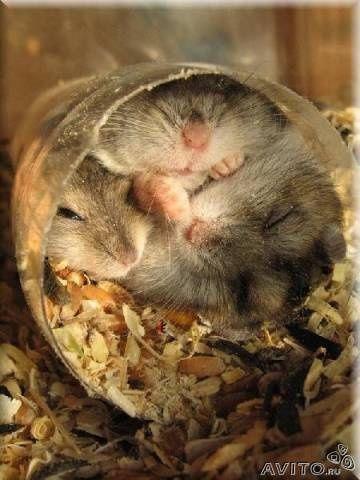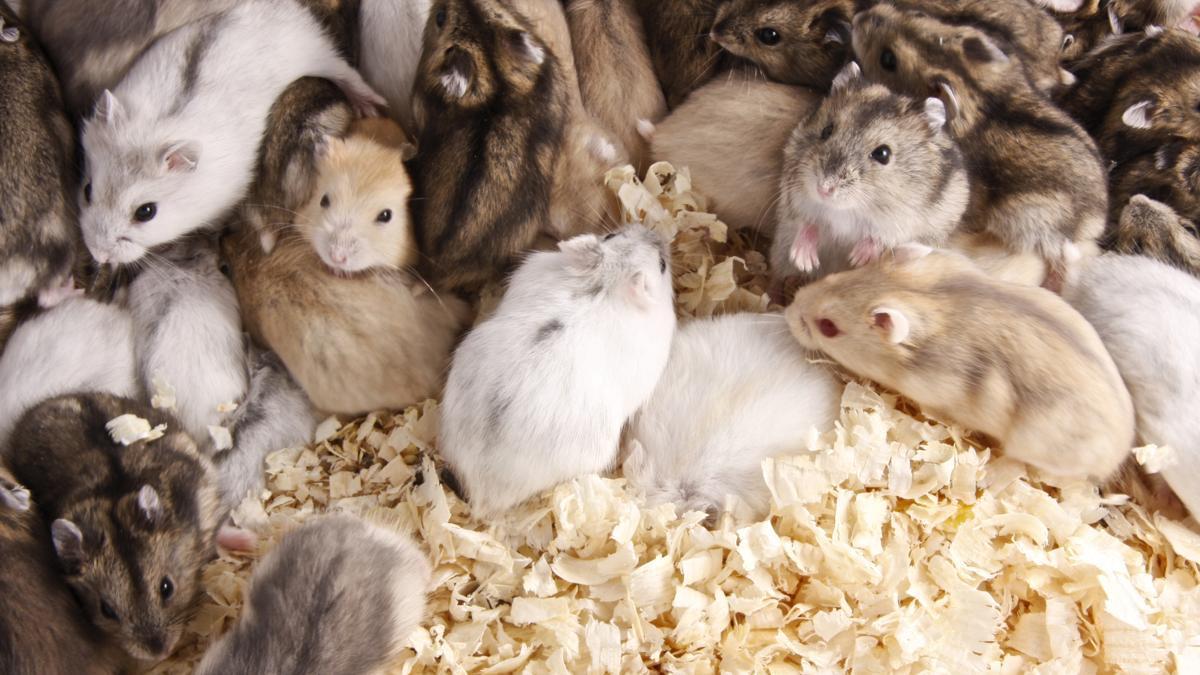The first image is the image on the left, the second image is the image on the right. Analyze the images presented: Is the assertion "There are 3 hamsters in the image pair" valid? Answer yes or no. No. 